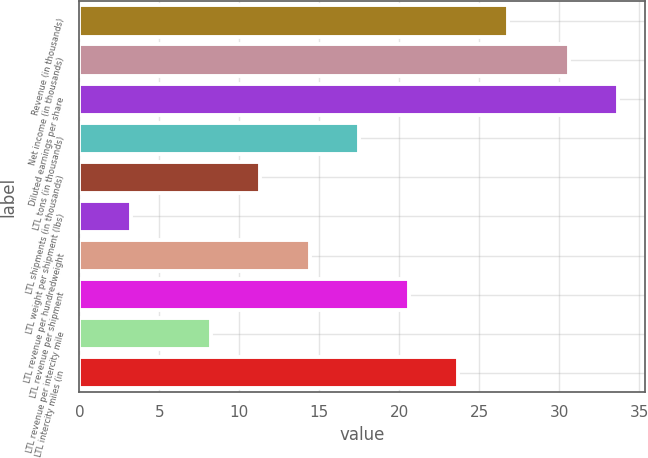Convert chart to OTSL. <chart><loc_0><loc_0><loc_500><loc_500><bar_chart><fcel>Revenue (in thousands)<fcel>Net income (in thousands)<fcel>Diluted earnings per share<fcel>LTL tons (in thousands)<fcel>LTL shipments (in thousands)<fcel>LTL weight per shipment (lbs)<fcel>LTL revenue per hundredweight<fcel>LTL revenue per shipment<fcel>LTL revenue per intercity mile<fcel>LTL intercity miles (in<nl><fcel>26.8<fcel>30.6<fcel>33.7<fcel>17.5<fcel>11.3<fcel>3.2<fcel>14.4<fcel>20.6<fcel>8.2<fcel>23.7<nl></chart> 